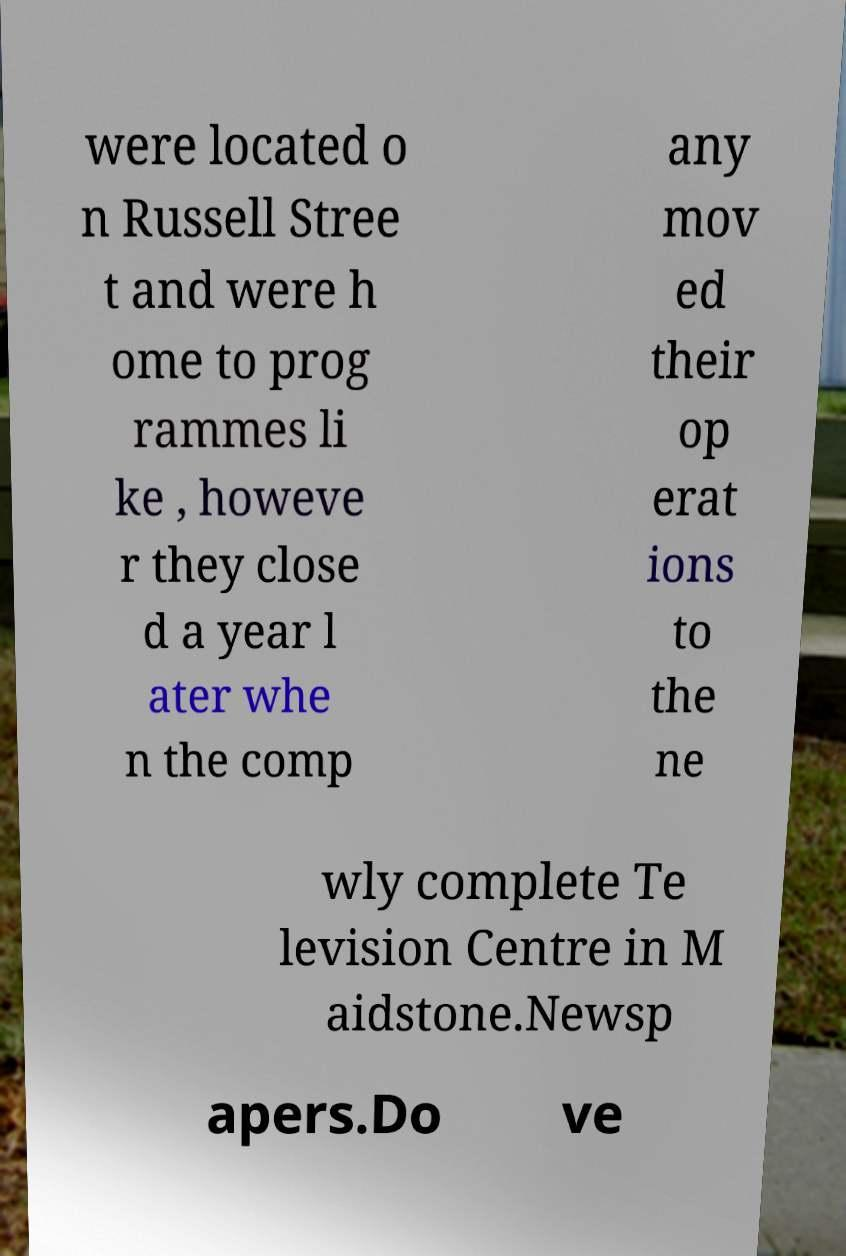Please read and relay the text visible in this image. What does it say? were located o n Russell Stree t and were h ome to prog rammes li ke , howeve r they close d a year l ater whe n the comp any mov ed their op erat ions to the ne wly complete Te levision Centre in M aidstone.Newsp apers.Do ve 